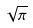<formula> <loc_0><loc_0><loc_500><loc_500>\sqrt { \pi }</formula> 